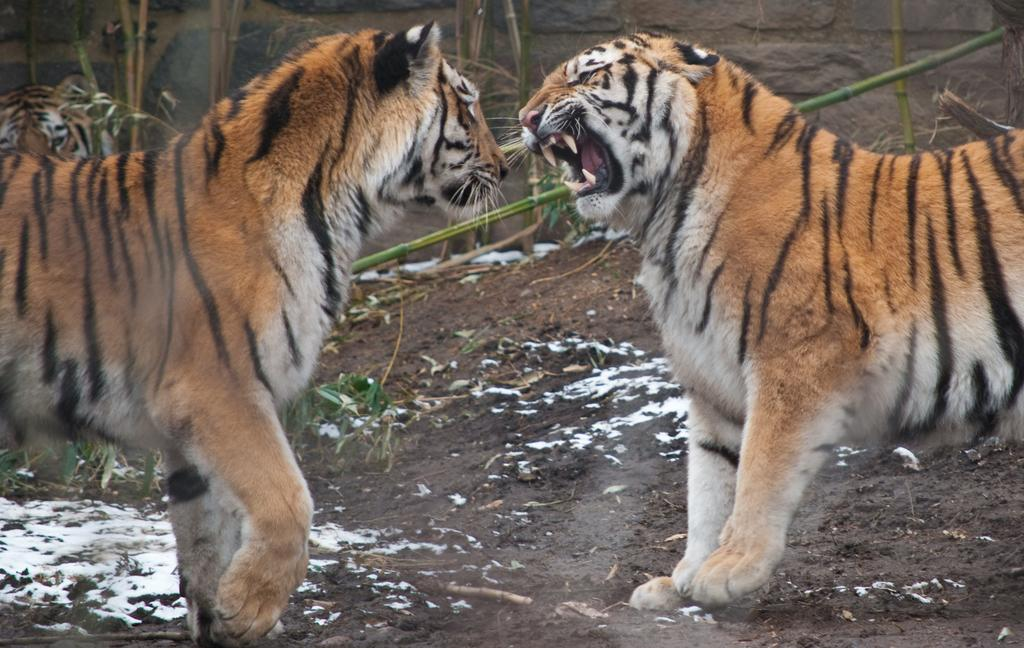What animals can be seen in the picture? There are tigers in the picture. What is the background of the picture? There is a wall in the picture. What type of vegetation might be present in the picture? Bamboo sticks may be present in the picture. What sound can be heard coming from the jar in the picture? There is no jar present in the picture, so it is not possible to determine what sound might be heard. 